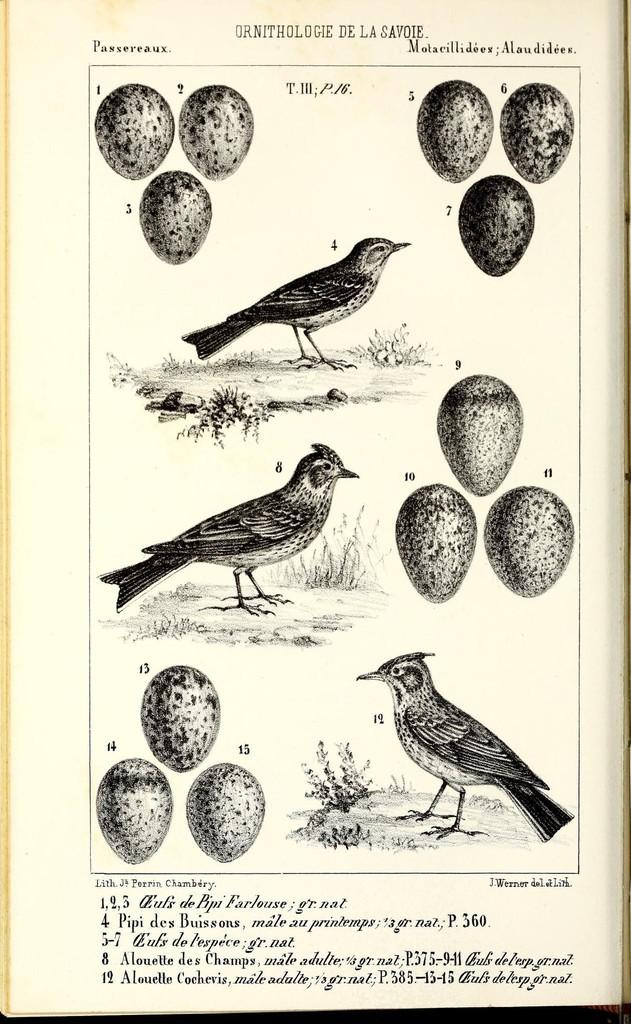What is depicted in the image? There is a picture of a paper in the image. What can be seen on the paper? The paper has a print of birds and eggs on it. Is there any text on the paper? Yes, there is printed text on the bottom of the paper. Can you see any giants wearing a veil in the image? There are no giants or veils present in the image; it features a picture of a paper with a print of birds and eggs and printed text on the bottom. 